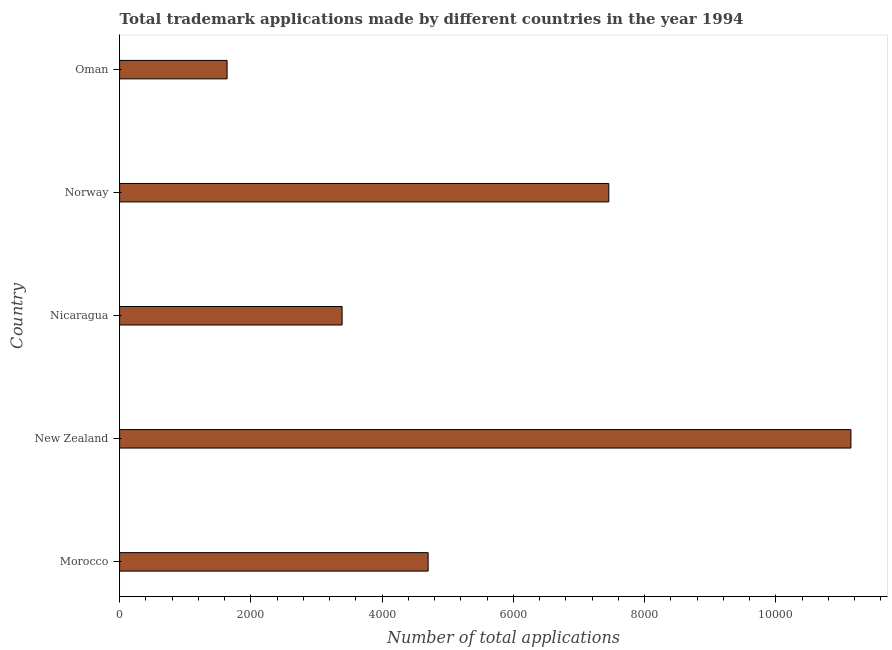Does the graph contain any zero values?
Your answer should be compact. No. What is the title of the graph?
Keep it short and to the point. Total trademark applications made by different countries in the year 1994. What is the label or title of the X-axis?
Keep it short and to the point. Number of total applications. What is the label or title of the Y-axis?
Offer a terse response. Country. What is the number of trademark applications in Nicaragua?
Keep it short and to the point. 3391. Across all countries, what is the maximum number of trademark applications?
Provide a short and direct response. 1.11e+04. Across all countries, what is the minimum number of trademark applications?
Give a very brief answer. 1638. In which country was the number of trademark applications maximum?
Your answer should be very brief. New Zealand. In which country was the number of trademark applications minimum?
Give a very brief answer. Oman. What is the sum of the number of trademark applications?
Offer a terse response. 2.83e+04. What is the difference between the number of trademark applications in New Zealand and Nicaragua?
Offer a very short reply. 7754. What is the average number of trademark applications per country?
Make the answer very short. 5666. What is the median number of trademark applications?
Your answer should be compact. 4702. In how many countries, is the number of trademark applications greater than 8800 ?
Provide a succinct answer. 1. What is the ratio of the number of trademark applications in Nicaragua to that in Oman?
Make the answer very short. 2.07. Is the number of trademark applications in Nicaragua less than that in Norway?
Provide a short and direct response. Yes. Is the difference between the number of trademark applications in New Zealand and Norway greater than the difference between any two countries?
Offer a very short reply. No. What is the difference between the highest and the second highest number of trademark applications?
Your answer should be compact. 3690. What is the difference between the highest and the lowest number of trademark applications?
Your response must be concise. 9507. In how many countries, is the number of trademark applications greater than the average number of trademark applications taken over all countries?
Keep it short and to the point. 2. Are all the bars in the graph horizontal?
Make the answer very short. Yes. How many countries are there in the graph?
Make the answer very short. 5. What is the Number of total applications of Morocco?
Your answer should be very brief. 4702. What is the Number of total applications of New Zealand?
Offer a very short reply. 1.11e+04. What is the Number of total applications in Nicaragua?
Offer a terse response. 3391. What is the Number of total applications in Norway?
Offer a very short reply. 7455. What is the Number of total applications of Oman?
Keep it short and to the point. 1638. What is the difference between the Number of total applications in Morocco and New Zealand?
Give a very brief answer. -6443. What is the difference between the Number of total applications in Morocco and Nicaragua?
Ensure brevity in your answer.  1311. What is the difference between the Number of total applications in Morocco and Norway?
Give a very brief answer. -2753. What is the difference between the Number of total applications in Morocco and Oman?
Make the answer very short. 3064. What is the difference between the Number of total applications in New Zealand and Nicaragua?
Ensure brevity in your answer.  7754. What is the difference between the Number of total applications in New Zealand and Norway?
Your answer should be very brief. 3690. What is the difference between the Number of total applications in New Zealand and Oman?
Keep it short and to the point. 9507. What is the difference between the Number of total applications in Nicaragua and Norway?
Make the answer very short. -4064. What is the difference between the Number of total applications in Nicaragua and Oman?
Your response must be concise. 1753. What is the difference between the Number of total applications in Norway and Oman?
Offer a terse response. 5817. What is the ratio of the Number of total applications in Morocco to that in New Zealand?
Offer a terse response. 0.42. What is the ratio of the Number of total applications in Morocco to that in Nicaragua?
Your answer should be very brief. 1.39. What is the ratio of the Number of total applications in Morocco to that in Norway?
Your answer should be compact. 0.63. What is the ratio of the Number of total applications in Morocco to that in Oman?
Keep it short and to the point. 2.87. What is the ratio of the Number of total applications in New Zealand to that in Nicaragua?
Make the answer very short. 3.29. What is the ratio of the Number of total applications in New Zealand to that in Norway?
Offer a terse response. 1.5. What is the ratio of the Number of total applications in New Zealand to that in Oman?
Give a very brief answer. 6.8. What is the ratio of the Number of total applications in Nicaragua to that in Norway?
Ensure brevity in your answer.  0.46. What is the ratio of the Number of total applications in Nicaragua to that in Oman?
Keep it short and to the point. 2.07. What is the ratio of the Number of total applications in Norway to that in Oman?
Your response must be concise. 4.55. 